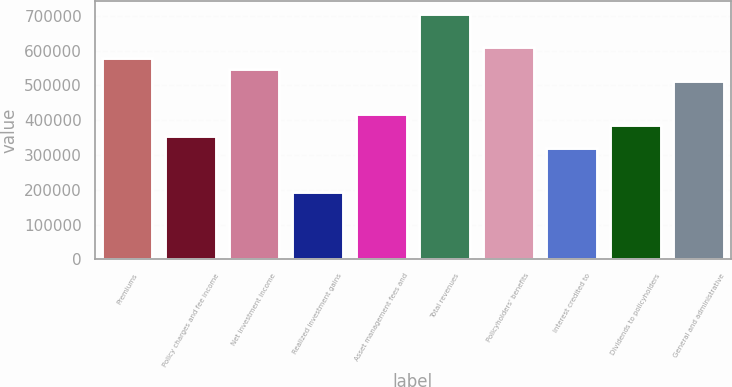Convert chart. <chart><loc_0><loc_0><loc_500><loc_500><bar_chart><fcel>Premiums<fcel>Policy charges and fee income<fcel>Net investment income<fcel>Realized investment gains<fcel>Asset management fees and<fcel>Total revenues<fcel>Policyholders' benefits<fcel>Interest credited to<fcel>Dividends to policyholders<fcel>General and administrative<nl><fcel>578292<fcel>353401<fcel>546165<fcel>192765<fcel>417656<fcel>706801<fcel>610419<fcel>321274<fcel>385528<fcel>514037<nl></chart> 